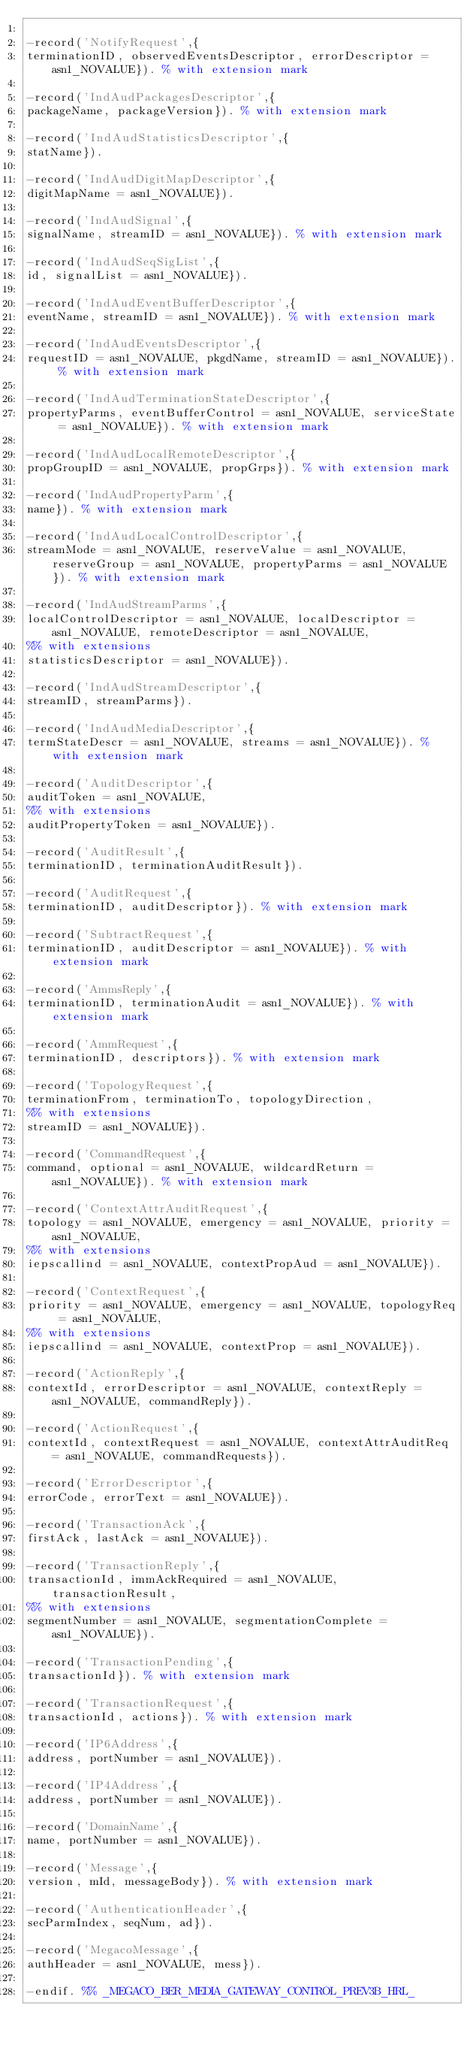<code> <loc_0><loc_0><loc_500><loc_500><_Erlang_>
-record('NotifyRequest',{
terminationID, observedEventsDescriptor, errorDescriptor = asn1_NOVALUE}). % with extension mark

-record('IndAudPackagesDescriptor',{
packageName, packageVersion}). % with extension mark

-record('IndAudStatisticsDescriptor',{
statName}).

-record('IndAudDigitMapDescriptor',{
digitMapName = asn1_NOVALUE}).

-record('IndAudSignal',{
signalName, streamID = asn1_NOVALUE}). % with extension mark

-record('IndAudSeqSigList',{
id, signalList = asn1_NOVALUE}).

-record('IndAudEventBufferDescriptor',{
eventName, streamID = asn1_NOVALUE}). % with extension mark

-record('IndAudEventsDescriptor',{
requestID = asn1_NOVALUE, pkgdName, streamID = asn1_NOVALUE}). % with extension mark

-record('IndAudTerminationStateDescriptor',{
propertyParms, eventBufferControl = asn1_NOVALUE, serviceState = asn1_NOVALUE}). % with extension mark

-record('IndAudLocalRemoteDescriptor',{
propGroupID = asn1_NOVALUE, propGrps}). % with extension mark

-record('IndAudPropertyParm',{
name}). % with extension mark

-record('IndAudLocalControlDescriptor',{
streamMode = asn1_NOVALUE, reserveValue = asn1_NOVALUE, reserveGroup = asn1_NOVALUE, propertyParms = asn1_NOVALUE}). % with extension mark

-record('IndAudStreamParms',{
localControlDescriptor = asn1_NOVALUE, localDescriptor = asn1_NOVALUE, remoteDescriptor = asn1_NOVALUE,
%% with extensions
statisticsDescriptor = asn1_NOVALUE}).

-record('IndAudStreamDescriptor',{
streamID, streamParms}).

-record('IndAudMediaDescriptor',{
termStateDescr = asn1_NOVALUE, streams = asn1_NOVALUE}). % with extension mark

-record('AuditDescriptor',{
auditToken = asn1_NOVALUE,
%% with extensions
auditPropertyToken = asn1_NOVALUE}).

-record('AuditResult',{
terminationID, terminationAuditResult}).

-record('AuditRequest',{
terminationID, auditDescriptor}). % with extension mark

-record('SubtractRequest',{
terminationID, auditDescriptor = asn1_NOVALUE}). % with extension mark

-record('AmmsReply',{
terminationID, terminationAudit = asn1_NOVALUE}). % with extension mark

-record('AmmRequest',{
terminationID, descriptors}). % with extension mark

-record('TopologyRequest',{
terminationFrom, terminationTo, topologyDirection,
%% with extensions
streamID = asn1_NOVALUE}).

-record('CommandRequest',{
command, optional = asn1_NOVALUE, wildcardReturn = asn1_NOVALUE}). % with extension mark

-record('ContextAttrAuditRequest',{
topology = asn1_NOVALUE, emergency = asn1_NOVALUE, priority = asn1_NOVALUE,
%% with extensions
iepscallind = asn1_NOVALUE, contextPropAud = asn1_NOVALUE}).

-record('ContextRequest',{
priority = asn1_NOVALUE, emergency = asn1_NOVALUE, topologyReq = asn1_NOVALUE,
%% with extensions
iepscallind = asn1_NOVALUE, contextProp = asn1_NOVALUE}).

-record('ActionReply',{
contextId, errorDescriptor = asn1_NOVALUE, contextReply = asn1_NOVALUE, commandReply}).

-record('ActionRequest',{
contextId, contextRequest = asn1_NOVALUE, contextAttrAuditReq = asn1_NOVALUE, commandRequests}).

-record('ErrorDescriptor',{
errorCode, errorText = asn1_NOVALUE}).

-record('TransactionAck',{
firstAck, lastAck = asn1_NOVALUE}).

-record('TransactionReply',{
transactionId, immAckRequired = asn1_NOVALUE, transactionResult,
%% with extensions
segmentNumber = asn1_NOVALUE, segmentationComplete = asn1_NOVALUE}).

-record('TransactionPending',{
transactionId}). % with extension mark

-record('TransactionRequest',{
transactionId, actions}). % with extension mark

-record('IP6Address',{
address, portNumber = asn1_NOVALUE}).

-record('IP4Address',{
address, portNumber = asn1_NOVALUE}).

-record('DomainName',{
name, portNumber = asn1_NOVALUE}).

-record('Message',{
version, mId, messageBody}). % with extension mark

-record('AuthenticationHeader',{
secParmIndex, seqNum, ad}).

-record('MegacoMessage',{
authHeader = asn1_NOVALUE, mess}).

-endif. %% _MEGACO_BER_MEDIA_GATEWAY_CONTROL_PREV3B_HRL_
</code> 